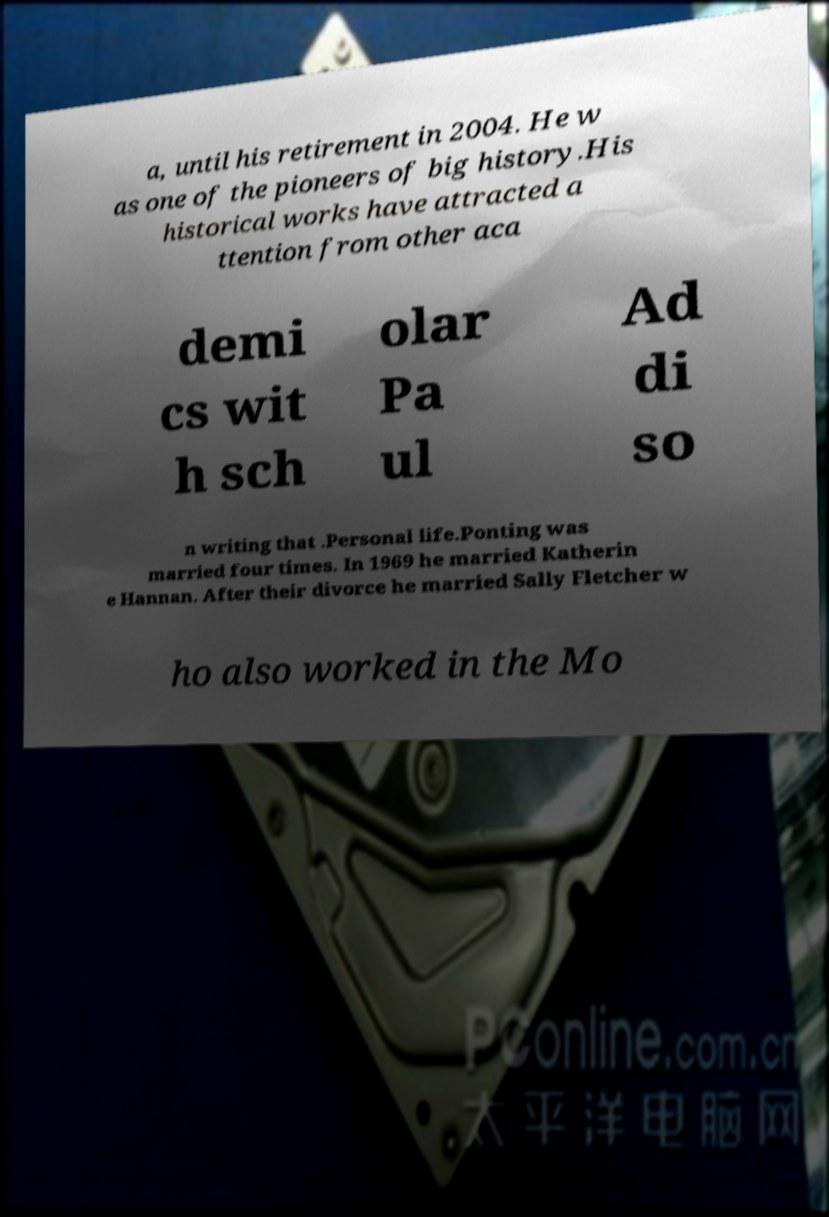For documentation purposes, I need the text within this image transcribed. Could you provide that? a, until his retirement in 2004. He w as one of the pioneers of big history.His historical works have attracted a ttention from other aca demi cs wit h sch olar Pa ul Ad di so n writing that .Personal life.Ponting was married four times. In 1969 he married Katherin e Hannan. After their divorce he married Sally Fletcher w ho also worked in the Mo 